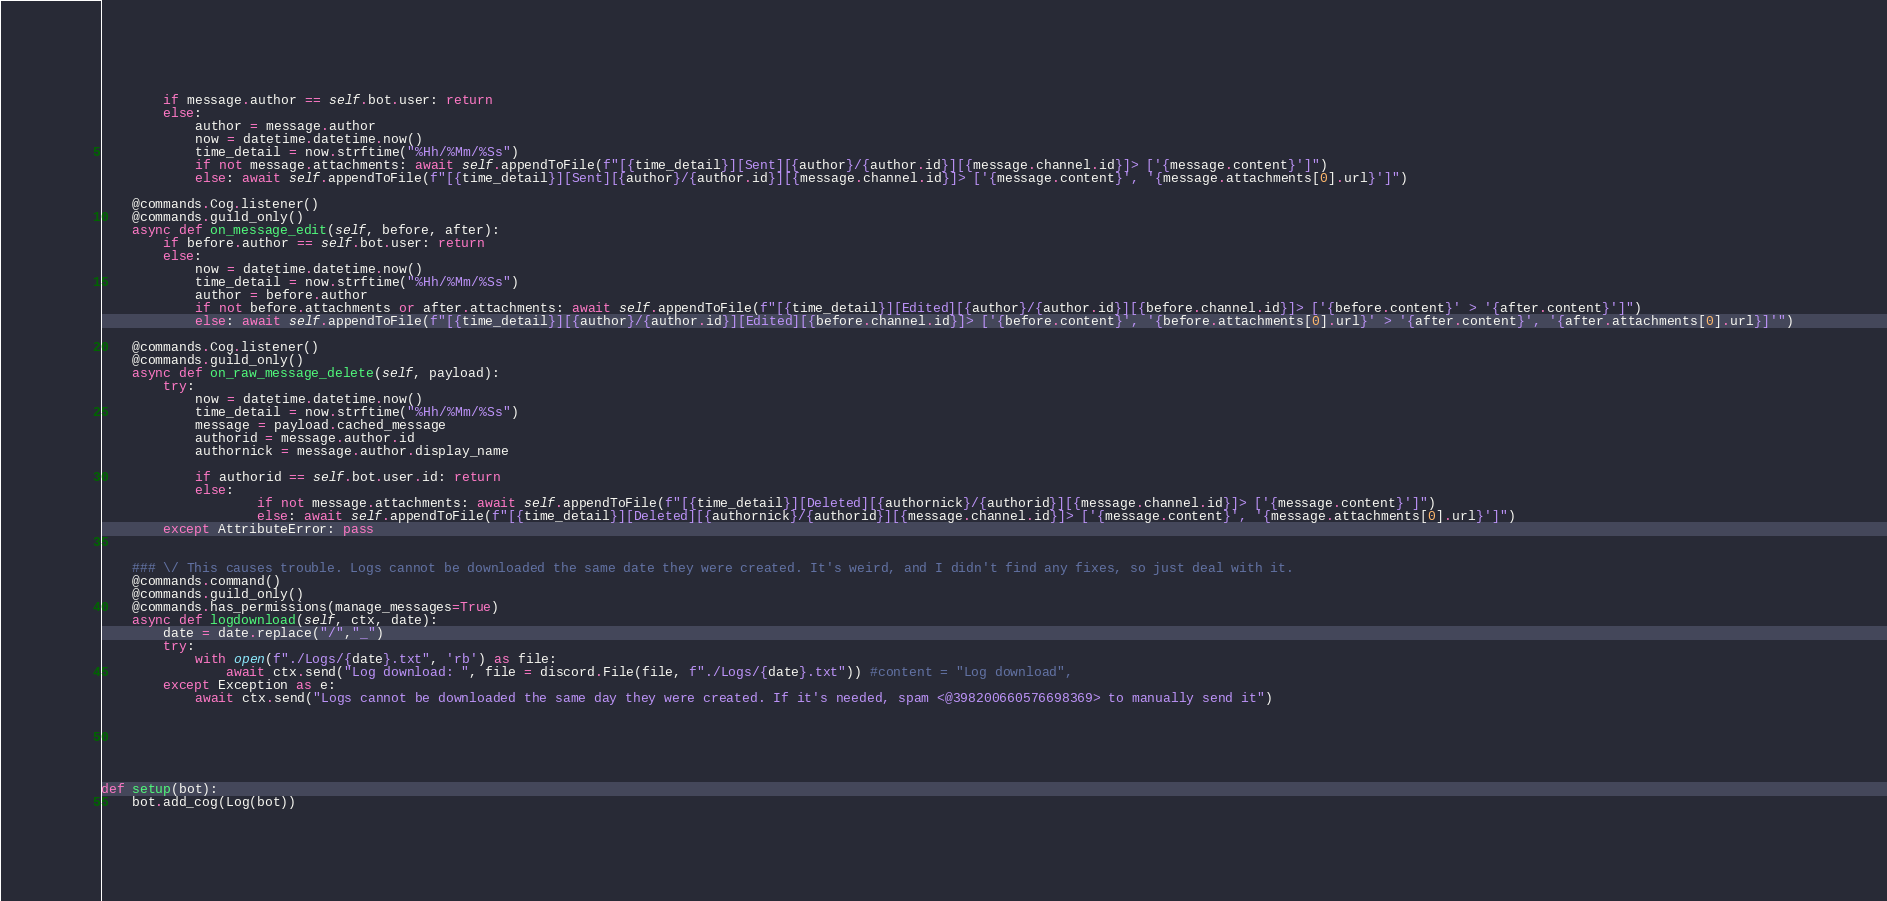<code> <loc_0><loc_0><loc_500><loc_500><_Python_>        if message.author == self.bot.user: return
        else:
            author = message.author
            now = datetime.datetime.now()
            time_detail = now.strftime("%Hh/%Mm/%Ss")
            if not message.attachments: await self.appendToFile(f"[{time_detail}][Sent][{author}/{author.id}][{message.channel.id}]> ['{message.content}']")
            else: await self.appendToFile(f"[{time_detail}][Sent][{author}/{author.id}][{message.channel.id}]> ['{message.content}', '{message.attachments[0].url}']")
    
    @commands.Cog.listener()
    @commands.guild_only()
    async def on_message_edit(self, before, after):
        if before.author == self.bot.user: return
        else:
            now = datetime.datetime.now()
            time_detail = now.strftime("%Hh/%Mm/%Ss")
            author = before.author
            if not before.attachments or after.attachments: await self.appendToFile(f"[{time_detail}][Edited][{author}/{author.id}][{before.channel.id}]> ['{before.content}' > '{after.content}']")
            else: await self.appendToFile(f"[{time_detail}][{author}/{author.id}][Edited][{before.channel.id}]> ['{before.content}', '{before.attachments[0].url}' > '{after.content}', '{after.attachments[0].url}]'")

    @commands.Cog.listener()
    @commands.guild_only()
    async def on_raw_message_delete(self, payload):
        try:
            now = datetime.datetime.now()
            time_detail = now.strftime("%Hh/%Mm/%Ss")
            message = payload.cached_message
            authorid = message.author.id
            authornick = message.author.display_name

            if authorid == self.bot.user.id: return
            else:
                    if not message.attachments: await self.appendToFile(f"[{time_detail}][Deleted][{authornick}/{authorid}][{message.channel.id}]> ['{message.content}']")
                    else: await self.appendToFile(f"[{time_detail}][Deleted][{authornick}/{authorid}][{message.channel.id}]> ['{message.content}', '{message.attachments[0].url}']")
        except AttributeError: pass


    ### \/ This causes trouble. Logs cannot be downloaded the same date they were created. It's weird, and I didn't find any fixes, so just deal with it.
    @commands.command()
    @commands.guild_only()
    @commands.has_permissions(manage_messages=True)
    async def logdownload(self, ctx, date):
        date = date.replace("/","_")
        try: 
            with open(f"./Logs/{date}.txt", 'rb') as file:
                await ctx.send("Log download: ", file = discord.File(file, f"./Logs/{date}.txt")) #content = "Log download", 
        except Exception as e:
            await ctx.send("Logs cannot be downloaded the same day they were created. If it's needed, spam <@398200660576698369> to manually send it")

            




def setup(bot):
    bot.add_cog(Log(bot))
</code> 